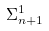Convert formula to latex. <formula><loc_0><loc_0><loc_500><loc_500>\Sigma _ { n + 1 } ^ { 1 }</formula> 